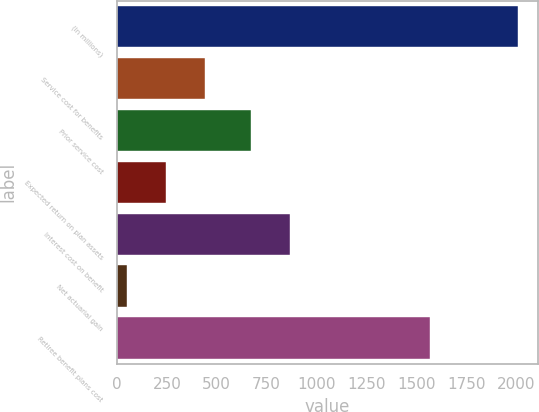Convert chart to OTSL. <chart><loc_0><loc_0><loc_500><loc_500><bar_chart><fcel>(In millions)<fcel>Service cost for benefits<fcel>Prior service cost<fcel>Expected return on plan assets<fcel>Interest cost on benefit<fcel>Net actuarial gain<fcel>Retiree benefit plans cost<nl><fcel>2008<fcel>440.8<fcel>673<fcel>244.9<fcel>868.9<fcel>49<fcel>1569<nl></chart> 